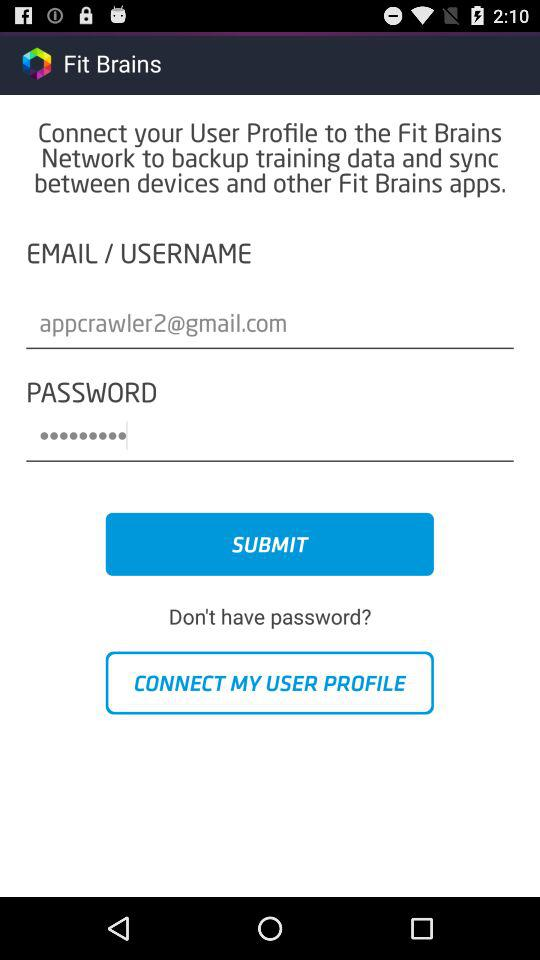How many text fields are there in this screen?
Answer the question using a single word or phrase. 2 